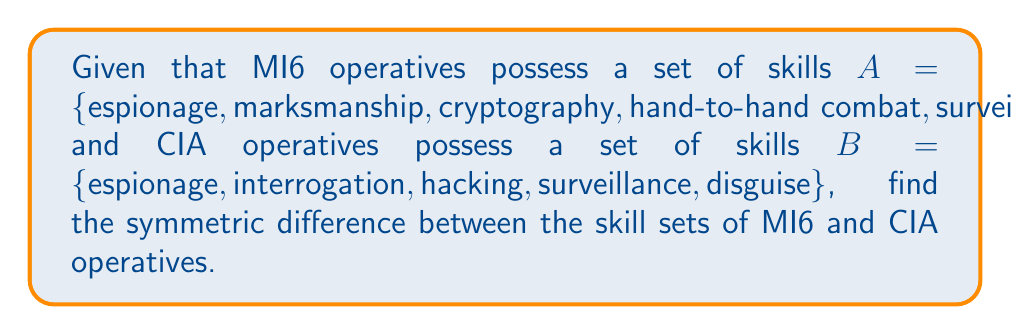Can you answer this question? To solve this problem, we need to understand the concept of symmetric difference in set theory and apply it to the given sets.

The symmetric difference between two sets A and B, denoted as $A \triangle B$, is defined as the set of elements that are in either A or B, but not in both. It can be expressed as:

$A \triangle B = (A \setminus B) \cup (B \setminus A)$

Where:
- $A \setminus B$ represents the elements in A that are not in B
- $B \setminus A$ represents the elements in B that are not in A

Let's break down the solution step-by-step:

1. Identify the elements unique to set A (MI6 skills):
   $A \setminus B = \{marksmanship, cryptography, hand-to-hand combat\}$

2. Identify the elements unique to set B (CIA skills):
   $B \setminus A = \{interrogation, hacking, disguise\}$

3. Take the union of these two sets to get the symmetric difference:
   $A \triangle B = \{marksmanship, cryptography, hand-to-hand combat\} \cup \{interrogation, hacking, disguise\}$

4. Combine the elements into a single set:
   $A \triangle B = \{marksmanship, cryptography, hand-to-hand combat, interrogation, hacking, disguise\}$

This result represents the skills that are unique to either MI6 or CIA operatives, but not common to both agencies.
Answer: The symmetric difference between MI6 and CIA operative skill sets is:

$A \triangle B = \{marksmanship, cryptography, hand-to-hand combat, interrogation, hacking, disguise\}$ 